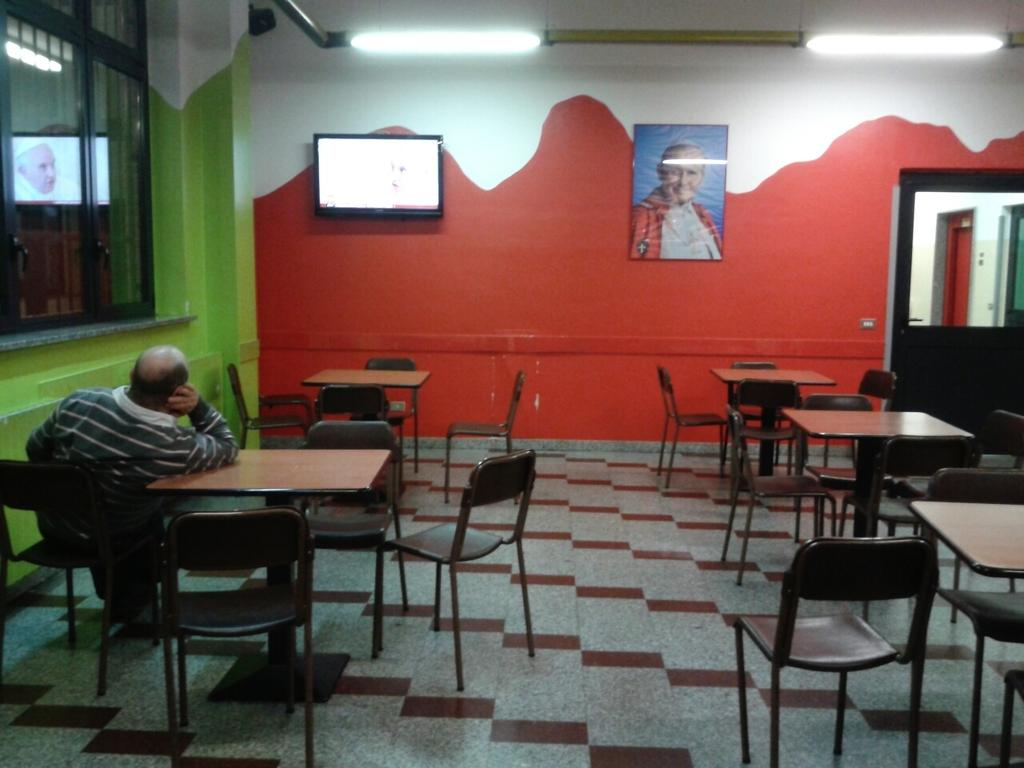What type of furniture is present in the image? There are chairs and tables in the image. What is the man in the image doing? The man is sitting on one of the chairs. What can be seen on the wall in the image? There is a photo frame on the wall in the image. What type of electronic device is present in the image? There is a display screen in the image. What architectural features are visible in the image? There is a door and windows in the image. What type of lighting is present in the image? Electric lights are visible in the image. What type of stick can be seen in the image? There is no stick present in the image. What type of bedroom is visible in the image? There is no bedroom present in the image. 